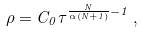Convert formula to latex. <formula><loc_0><loc_0><loc_500><loc_500>\rho = C _ { 0 } \tau ^ { \frac { N } { \alpha ( N + 1 ) } - 1 } \, ,</formula> 